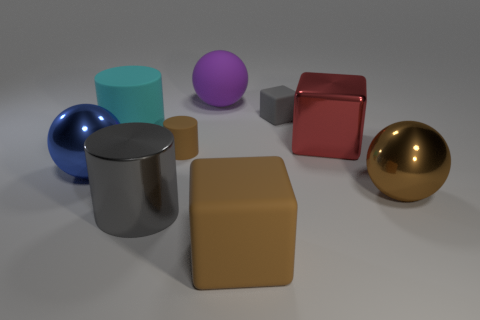Is the number of tiny brown matte cylinders that are to the right of the red shiny thing less than the number of big matte objects behind the gray metallic cylinder?
Your answer should be compact. Yes. There is a brown matte object to the left of the sphere behind the matte cylinder in front of the cyan rubber cylinder; what shape is it?
Your answer should be compact. Cylinder. What shape is the thing that is both to the left of the gray matte thing and behind the cyan cylinder?
Keep it short and to the point. Sphere. Are there any purple balls that have the same material as the brown cylinder?
Your response must be concise. Yes. There is a matte object that is the same color as the large shiny cylinder; what is its size?
Give a very brief answer. Small. What color is the cube that is right of the tiny gray thing?
Your answer should be compact. Red. There is a blue shiny thing; is it the same shape as the large rubber thing behind the cyan object?
Provide a succinct answer. Yes. Is there a object that has the same color as the tiny matte block?
Offer a terse response. Yes. There is a gray cube that is the same material as the large purple thing; what size is it?
Give a very brief answer. Small. Is the color of the big metal cylinder the same as the tiny rubber block?
Your answer should be very brief. Yes. 